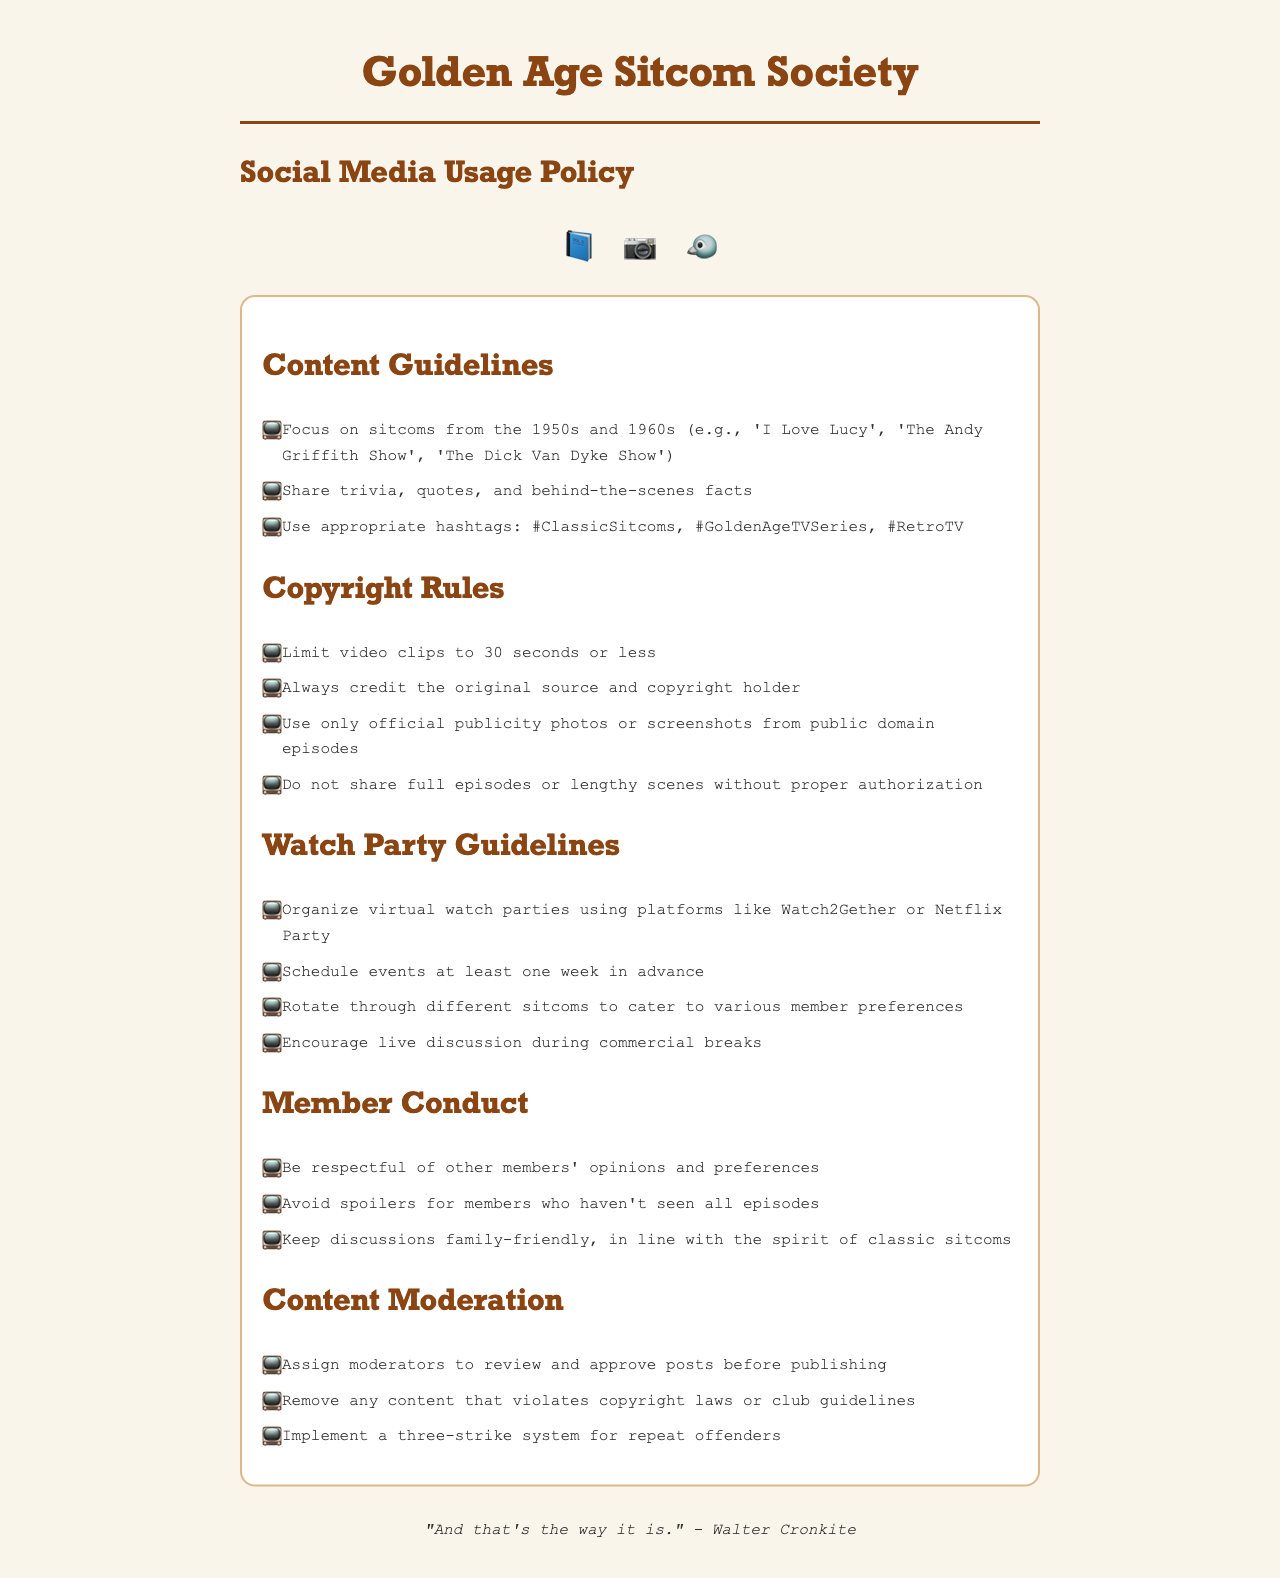what are the focus years for sitcoms? The document specifies that the focus years for sitcoms are from the 1950s and 1960s.
Answer: 1950s and 1960s what is the maximum length for video clips? The policy states that the maximum length for video clips is 30 seconds or less.
Answer: 30 seconds which platforms can be used for organizing watch parties? The document mentions that virtual watch parties can be organized using platforms like Watch2Gether or Netflix Party.
Answer: Watch2Gether or Netflix Party how many days in advance should events be scheduled? The guidelines dictate that events should be scheduled at least one week in advance.
Answer: one week what should be avoided in discussions? The policy emphasizes that spoilers for members who haven't seen all episodes should be avoided in discussions.
Answer: spoilers how many strikes do repeat offenders get before action is taken? The content moderation section outlines a three-strike system for repeat offenders.
Answer: three strikes which hashtags are suggested for sharing content? The document recommends using hashtags like #ClassicSitcoms, #GoldenAgeTVSeries, and #RetroTV.
Answer: #ClassicSitcoms, #GoldenAgeTVSeries, #RetroTV what is required when sharing copyrighted materials? The policy states that it is required to always credit the original source and copyright holder when sharing copyrighted materials.
Answer: credit the original source and copyright holder 